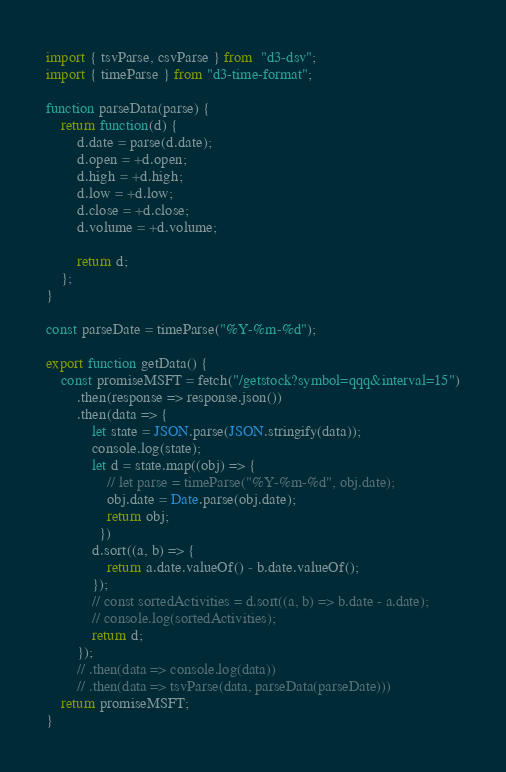Convert code to text. <code><loc_0><loc_0><loc_500><loc_500><_JavaScript_>

import { tsvParse, csvParse } from  "d3-dsv";
import { timeParse } from "d3-time-format";

function parseData(parse) {
	return function(d) {
		d.date = parse(d.date);
		d.open = +d.open;
		d.high = +d.high;
		d.low = +d.low;
		d.close = +d.close;
		d.volume = +d.volume;

		return d;
	};
}

const parseDate = timeParse("%Y-%m-%d");

export function getData() {
	const promiseMSFT = fetch("/getstock?symbol=qqq&interval=15")
		.then(response => response.json())
        .then(data => {
            let state = JSON.parse(JSON.stringify(data));
            console.log(state);
            let d = state.map((obj) => {
                // let parse = timeParse("%Y-%m-%d", obj.date);
                obj.date = Date.parse(obj.date);
                return obj;
              })
            d.sort((a, b) => {
				return a.date.valueOf() - b.date.valueOf();
			});
            // const sortedActivities = d.sort((a, b) => b.date - a.date);
            // console.log(sortedActivities);
            return d;
        });
        // .then(data => console.log(data))
		// .then(data => tsvParse(data, parseData(parseDate)))
	return promiseMSFT;
}
</code> 